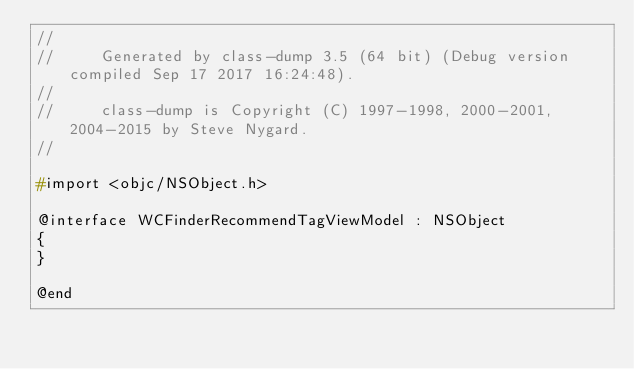<code> <loc_0><loc_0><loc_500><loc_500><_C_>//
//     Generated by class-dump 3.5 (64 bit) (Debug version compiled Sep 17 2017 16:24:48).
//
//     class-dump is Copyright (C) 1997-1998, 2000-2001, 2004-2015 by Steve Nygard.
//

#import <objc/NSObject.h>

@interface WCFinderRecommendTagViewModel : NSObject
{
}

@end

</code> 